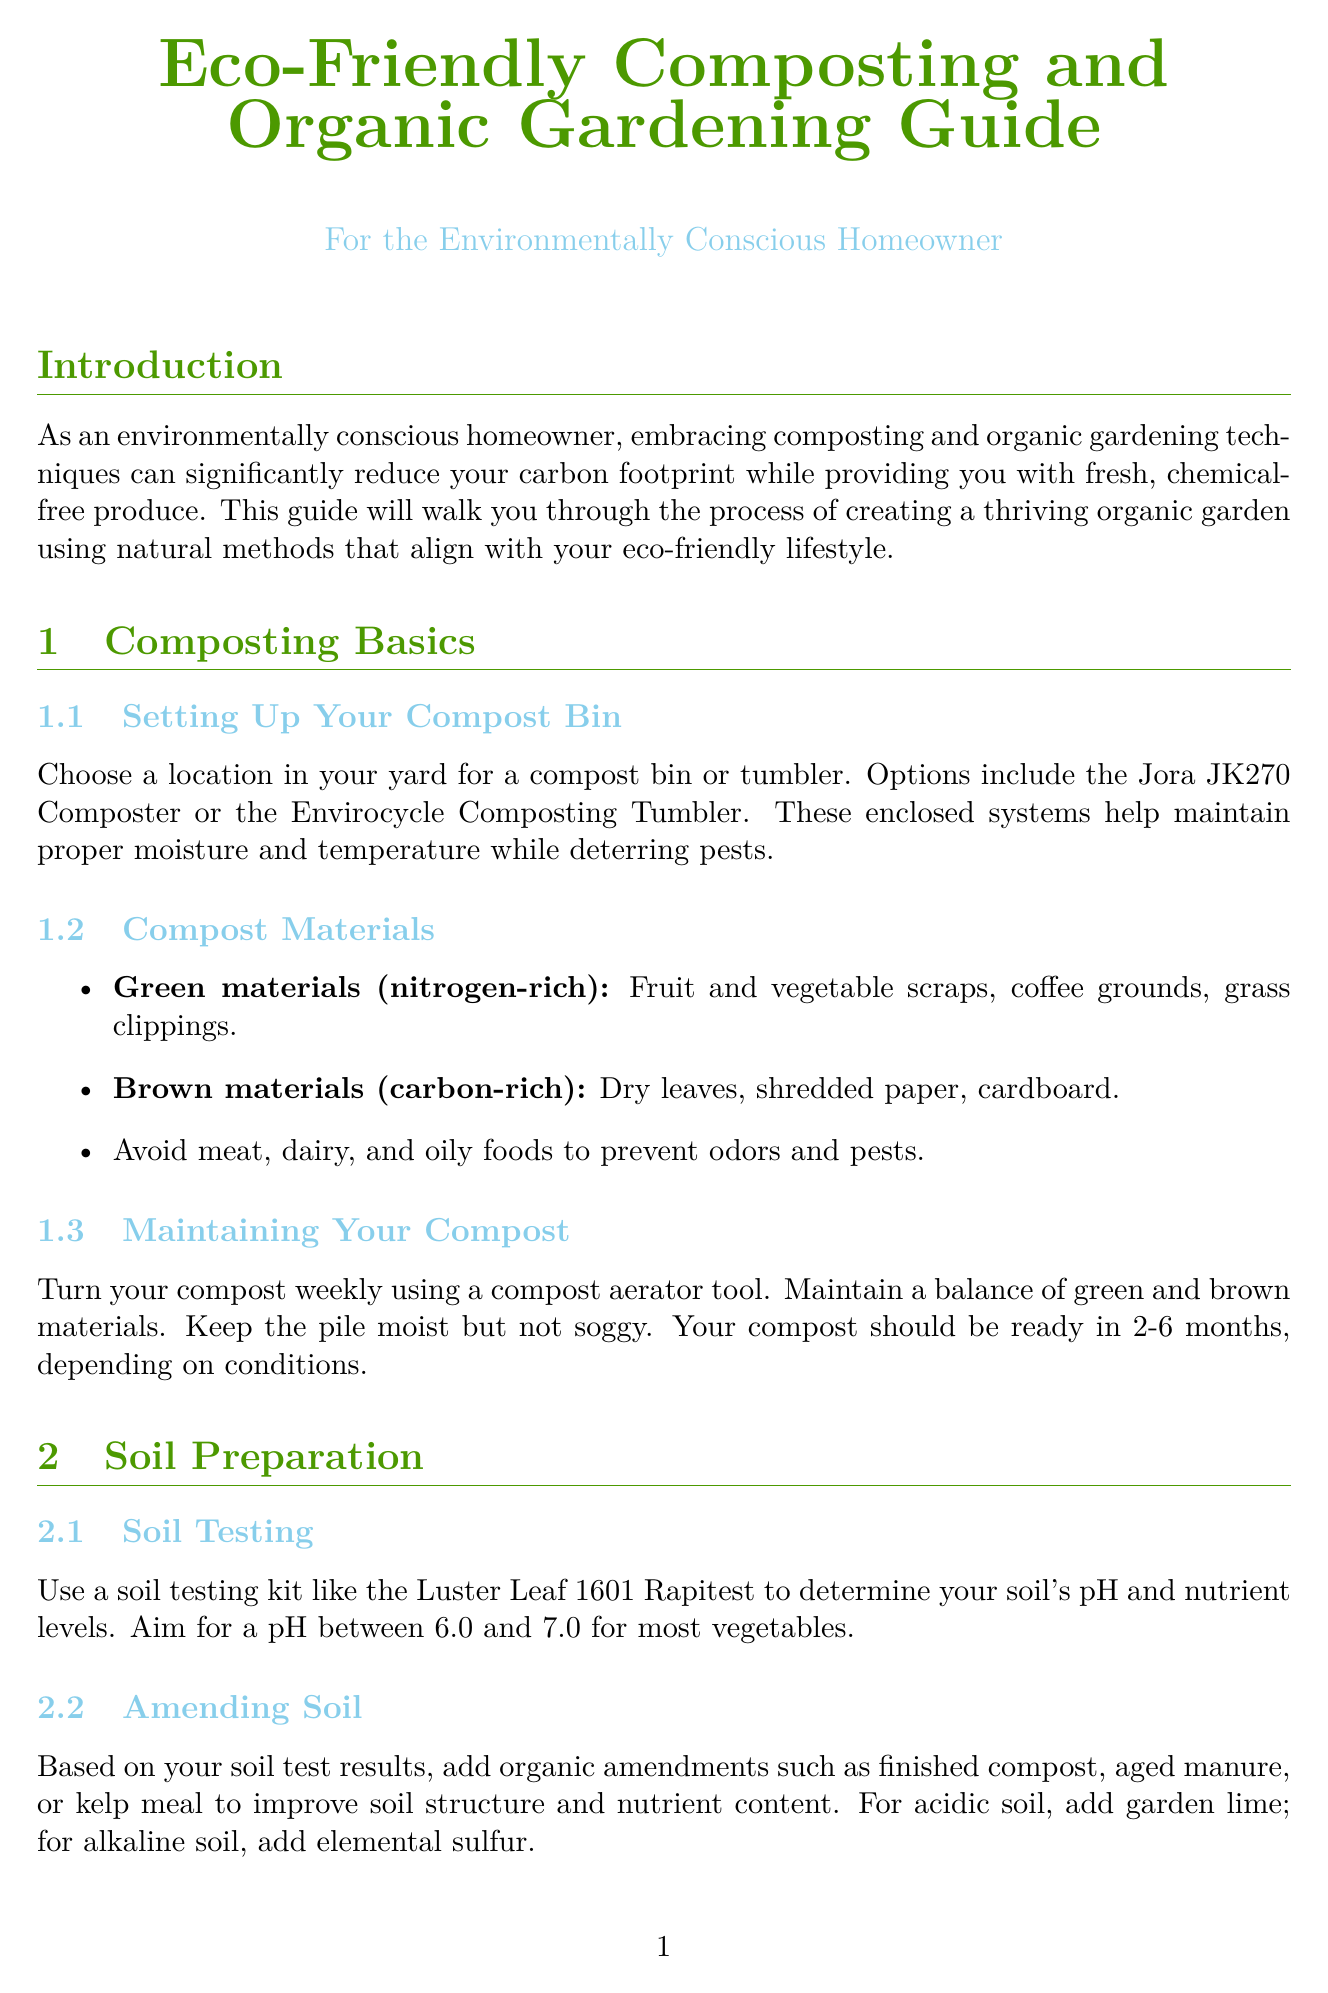what is the title of the guide? The title of the guide is provided in the header of the document.
Answer: Eco-Friendly Composting and Organic Gardening Guide how long does it take for compost to be ready? The document mentions the time it takes for compost to be ready based on conditions.
Answer: 2-6 months what is a nitrogen-rich green material mentioned in the guide? The guide lists specific nitrogen-rich materials to be used in composting.
Answer: Fruit and vegetable scraps what pH level is ideal for most vegetables? The guide specifies the desired pH range for most vegetables to thrive.
Answer: 6.0 to 7.0 which method is used to preserve soil structure? The document discusses a method that helps in maintaining the soil’s natural character.
Answer: No-Till Method what tool is suggested for harvesting root vegetables? The guide recommends a specific tool for digging up root vegetables without causing damage.
Answer: Garden fork what type of irrigation system does the guide recommend? The document specifies a particular irrigation system beneficial for conserving water.
Answer: Drip Irrigation what crop should be planted next to tomatoes according to companion planting? The guide includes recommendations for companion planting to enhance pest control.
Answer: Basil what container type is suggested for storing harvested produce? The guide discusses environmentally friendly storage solutions for fresh produce.
Answer: Reusable produce bags 